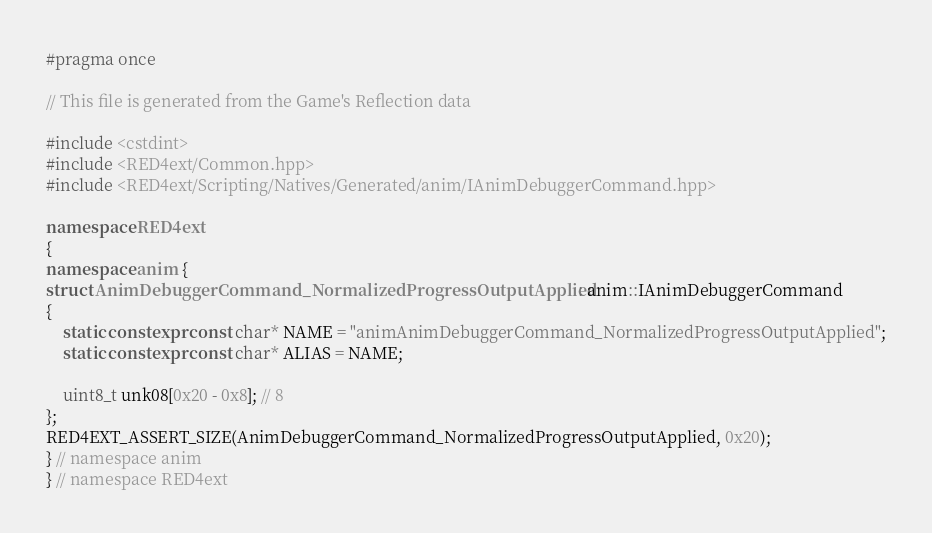Convert code to text. <code><loc_0><loc_0><loc_500><loc_500><_C++_>#pragma once

// This file is generated from the Game's Reflection data

#include <cstdint>
#include <RED4ext/Common.hpp>
#include <RED4ext/Scripting/Natives/Generated/anim/IAnimDebuggerCommand.hpp>

namespace RED4ext
{
namespace anim { 
struct AnimDebuggerCommand_NormalizedProgressOutputApplied : anim::IAnimDebuggerCommand
{
    static constexpr const char* NAME = "animAnimDebuggerCommand_NormalizedProgressOutputApplied";
    static constexpr const char* ALIAS = NAME;

    uint8_t unk08[0x20 - 0x8]; // 8
};
RED4EXT_ASSERT_SIZE(AnimDebuggerCommand_NormalizedProgressOutputApplied, 0x20);
} // namespace anim
} // namespace RED4ext
</code> 